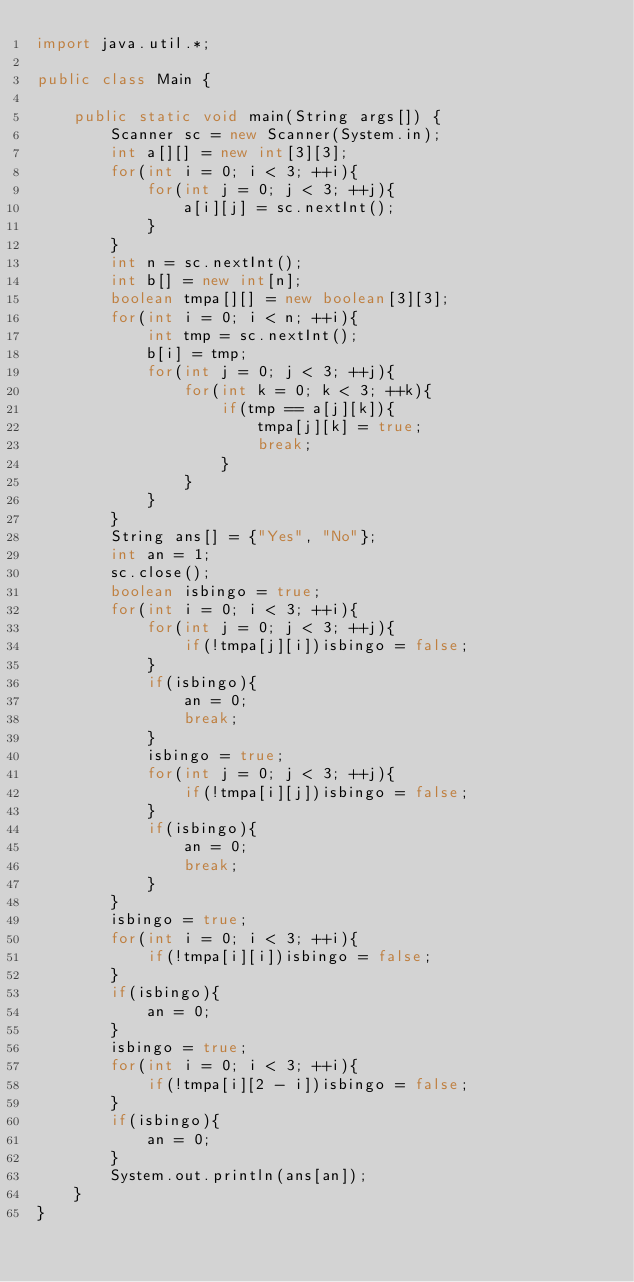Convert code to text. <code><loc_0><loc_0><loc_500><loc_500><_Java_>import java.util.*;

public class Main {

	public static void main(String args[]) {
		Scanner sc = new Scanner(System.in);
		int a[][] = new int[3][3];
		for(int i = 0; i < 3; ++i){
			for(int j = 0; j < 3; ++j){
				a[i][j] = sc.nextInt();
			}
		}
		int n = sc.nextInt();
		int b[] = new int[n];
		boolean tmpa[][] = new boolean[3][3];
		for(int i = 0; i < n; ++i){
			int tmp = sc.nextInt();
			b[i] = tmp;
			for(int j = 0; j < 3; ++j){
				for(int k = 0; k < 3; ++k){
					if(tmp == a[j][k]){
						tmpa[j][k] = true;
						break;
					}
				}
			}
		}
		String ans[] = {"Yes", "No"};
		int an = 1;
		sc.close();
		boolean isbingo = true;
		for(int i = 0; i < 3; ++i){
			for(int j = 0; j < 3; ++j){
				if(!tmpa[j][i])isbingo = false;
			}
			if(isbingo){
				an = 0;
				break;
			}
			isbingo = true;
			for(int j = 0; j < 3; ++j){
				if(!tmpa[i][j])isbingo = false;
			}
			if(isbingo){
				an = 0;
				break;
			}
		}
		isbingo = true;
		for(int i = 0; i < 3; ++i){
			if(!tmpa[i][i])isbingo = false;
		}
		if(isbingo){
			an = 0;
		}
		isbingo = true;
		for(int i = 0; i < 3; ++i){
			if(!tmpa[i][2 - i])isbingo = false;
		}
		if(isbingo){
			an = 0;
		}
		System.out.println(ans[an]);
	}
}
</code> 